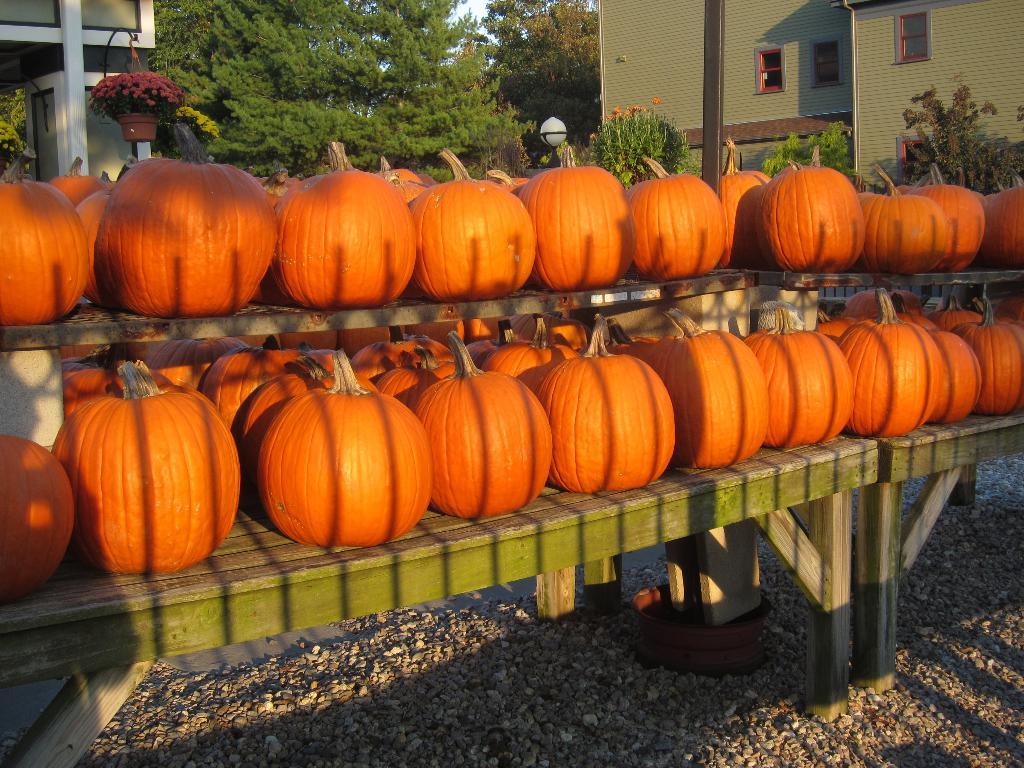What type of objects can be seen on tables in the image? There are pumpkins on tables in the image. What type of natural elements can be seen on the ground in the image? There are stones on the ground in the image. What type of plant is visible in the image? There is a house plant in the image. What type of structure is visible in the image? There is a building with windows in the image. What type of vegetation can be seen in the background of the image? Trees are present in the background of the image. What type of class is being taught in the image? There is no class or teaching activity visible in the image. How does the uncle transport the pumpkins in the image? There is no uncle or transportation of pumpkins depicted in the image. 